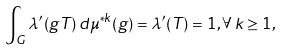Convert formula to latex. <formula><loc_0><loc_0><loc_500><loc_500>\int _ { G } \lambda ^ { \prime } ( g T ) \, d \mu ^ { * k } ( g ) = \lambda ^ { \prime } ( T ) = 1 , \forall \, k \geq 1 ,</formula> 